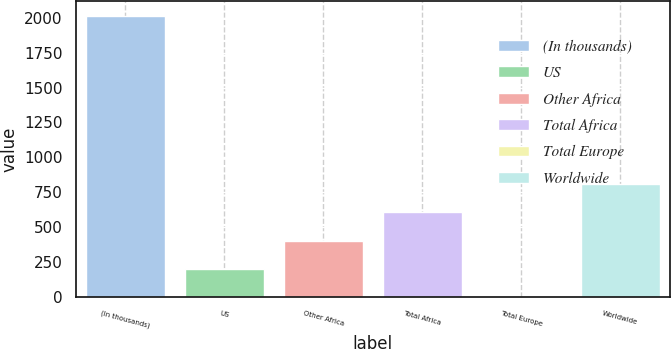Convert chart. <chart><loc_0><loc_0><loc_500><loc_500><bar_chart><fcel>(In thousands)<fcel>US<fcel>Other Africa<fcel>Total Africa<fcel>Total Europe<fcel>Worldwide<nl><fcel>2016<fcel>202.5<fcel>404<fcel>605.5<fcel>1<fcel>807<nl></chart> 